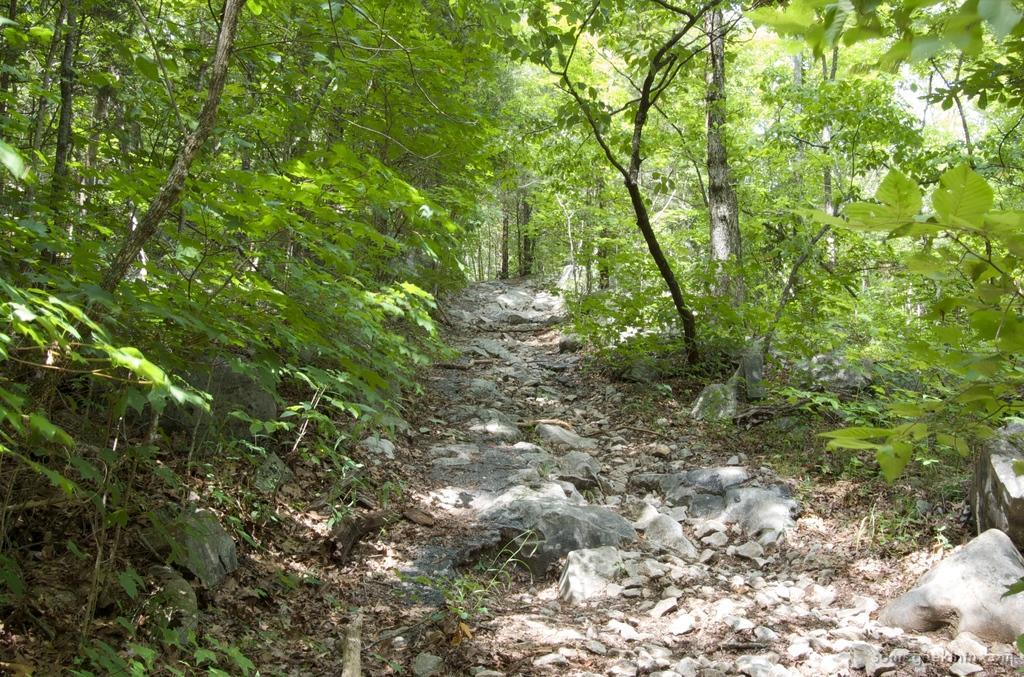What type of vegetation can be seen in the background of the image? There are trees in the background of the image. What can be found at the bottom of the image? Rocks and dry leaves are visible at the bottom of the image. What is the surface visible at the bottom of the image? The ground is visible at the bottom of the image. Where is the text located in the image? The text is in the bottom right corner of the image. What type of zephyr is blowing through the trees in the image? There is no mention of a zephyr or any wind in the image; it only shows trees in the background. How does the comb help in the image? There is no comb present in the image, so it cannot be used to help with anything in this context. 